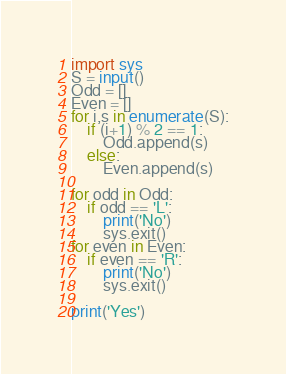<code> <loc_0><loc_0><loc_500><loc_500><_Python_>import sys
S = input()
Odd = []
Even = []
for i,s in enumerate(S):
    if (i+1) % 2 == 1:
        Odd.append(s)
    else:
        Even.append(s)

for odd in Odd:
    if odd == 'L':
        print('No')
        sys.exit()
for even in Even:
    if even == 'R':
        print('No')
        sys.exit()

print('Yes')
</code> 